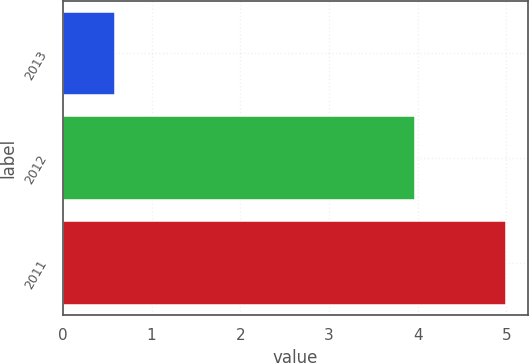<chart> <loc_0><loc_0><loc_500><loc_500><bar_chart><fcel>2013<fcel>2012<fcel>2011<nl><fcel>0.59<fcel>3.97<fcel>4.99<nl></chart> 